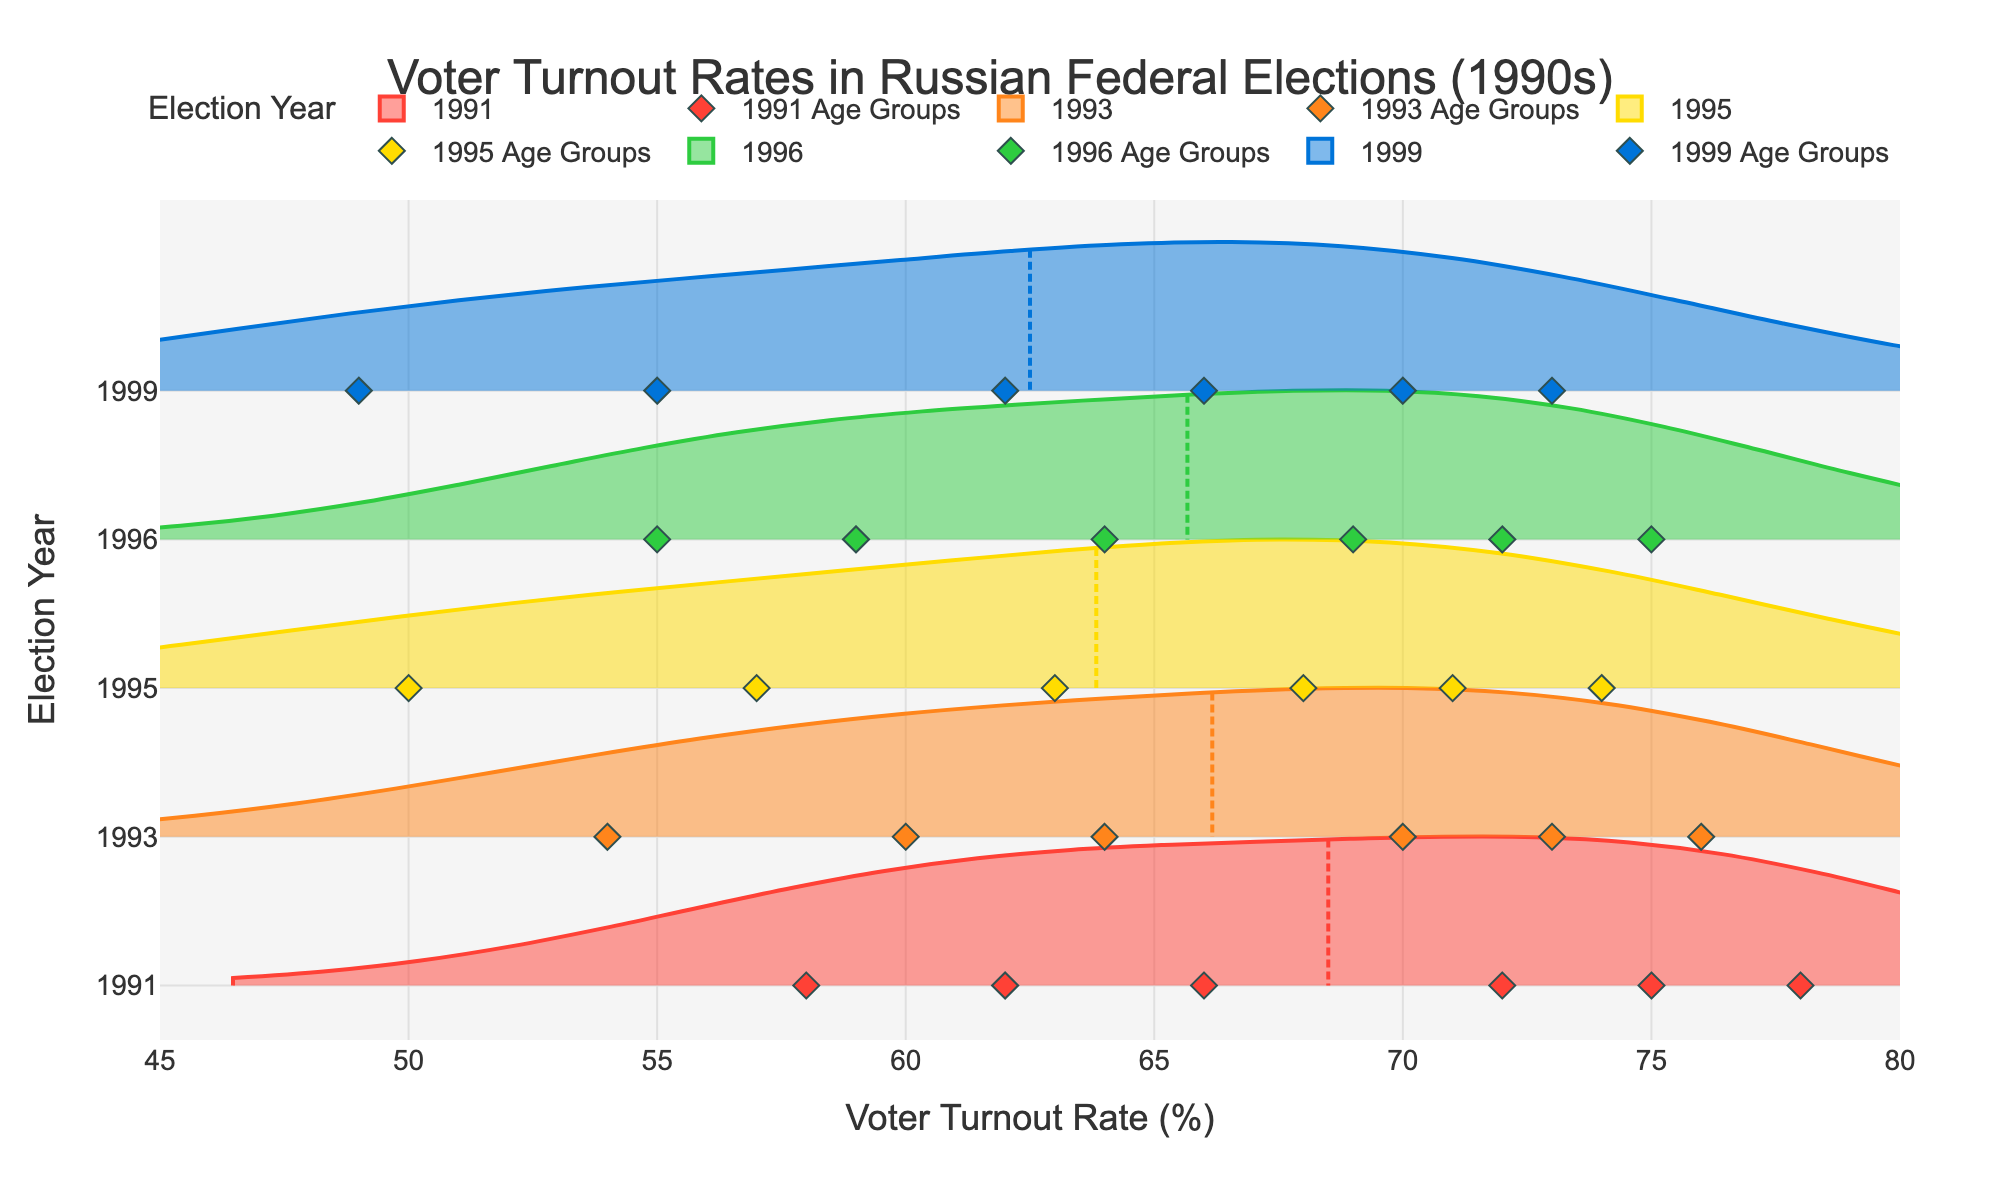What is the title of the figure? The title is centered at the top of the figure and clearly states the theme of the visualization about voter turnout rates in Russian federal elections during the 1990s.
Answer: Voter Turnout Rates in Russian Federal Elections (1990s) What is the voter turnout rate for the 18-24 age group in 1999? Locate the 18-24 age group in the data corresponding to the year 1999 and find the corresponding turnout rate, which is shown in the scatter plot.
Answer: 49% Which age group had the highest turnout rate in 1991? By visually inspecting the scatter plot points for 1991, the age group with the highest turnout rate can be identified as the one with the leftmost point.
Answer: 65+ What is the average voter turnout rate across all age groups in 1995? Sum the voter turnout rates for all age groups in 1995 and then divide by the number of age groups (6). Calculation: (50 + 57 + 63 + 68 + 71 + 74) / 6 = 63.83
Answer: 63.83% How did the voter turnout rate for the 45-54 age group change from 1991 to 1999? Subtract the 1999 turnout rate for the 45-54 age group from its 1991 turnout rate. Calculation: 72 - 66 = 6
Answer: Decreased by 6% Which year shows the least variation in voter turnout rates across all age groups? The year with the narrowest spread of scatter plot points will indicate the least variation. Visual inspection of the density plots and scatter points indicates which year has the tightest grouping.
Answer: 1996 Do older age groups consistently show higher voter turnout rates compared to younger age groups across all years? By comparing the scatter plot points vertically, we can observe the general trend of turnout rates from younger to older age groups for each year. Older age groups are always towards the left in each year, indicating higher rates.
Answer: Yes What is the turnout rate difference between the 18-24 and the 65+ age groups for the year 1993? Subtract the turnout rate of the 18-24 age group from that of the 65+ age group for 1993. Calculation: 76 - 54 = 22
Answer: 22% In which year did the 25-34 age group's turnout rate surpass 60%? Identify the year in the scatter plot where the 25-34 age group's turnout rate is above 60%. The corresponding point will be to the left of the 60% mark.
Answer: 1991 and 1993 What trend do we observe regarding voter turnout rates for the 55-64 age group from 1991 to 1999? Observe the data points for the 55-64 age group from 1991 to 1999 and note the pattern of change; each point is slightly decreasing each year.
Answer: Decreasing trend 